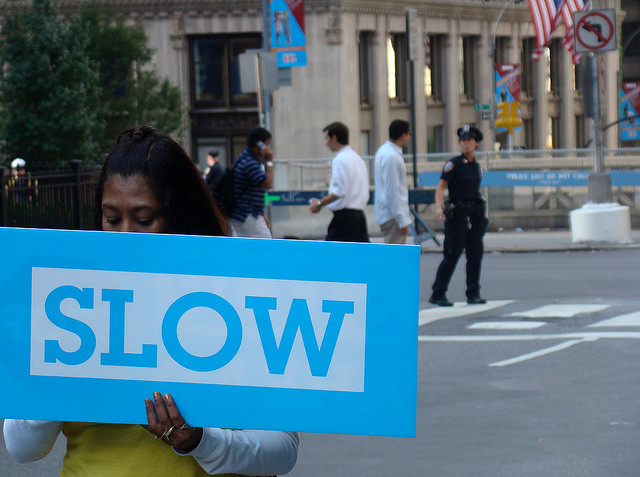Identify and read out the text in this image. SLOW 